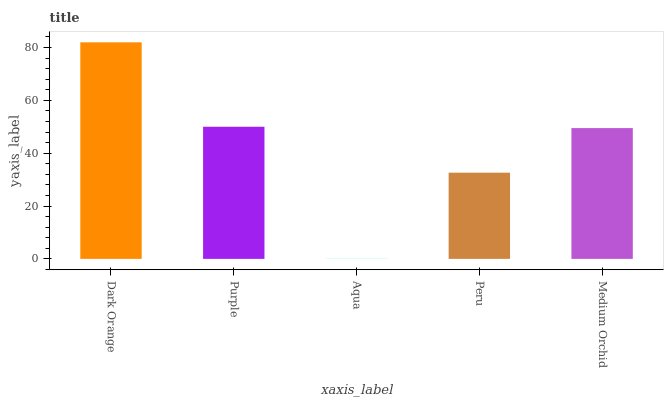Is Aqua the minimum?
Answer yes or no. Yes. Is Dark Orange the maximum?
Answer yes or no. Yes. Is Purple the minimum?
Answer yes or no. No. Is Purple the maximum?
Answer yes or no. No. Is Dark Orange greater than Purple?
Answer yes or no. Yes. Is Purple less than Dark Orange?
Answer yes or no. Yes. Is Purple greater than Dark Orange?
Answer yes or no. No. Is Dark Orange less than Purple?
Answer yes or no. No. Is Medium Orchid the high median?
Answer yes or no. Yes. Is Medium Orchid the low median?
Answer yes or no. Yes. Is Dark Orange the high median?
Answer yes or no. No. Is Aqua the low median?
Answer yes or no. No. 